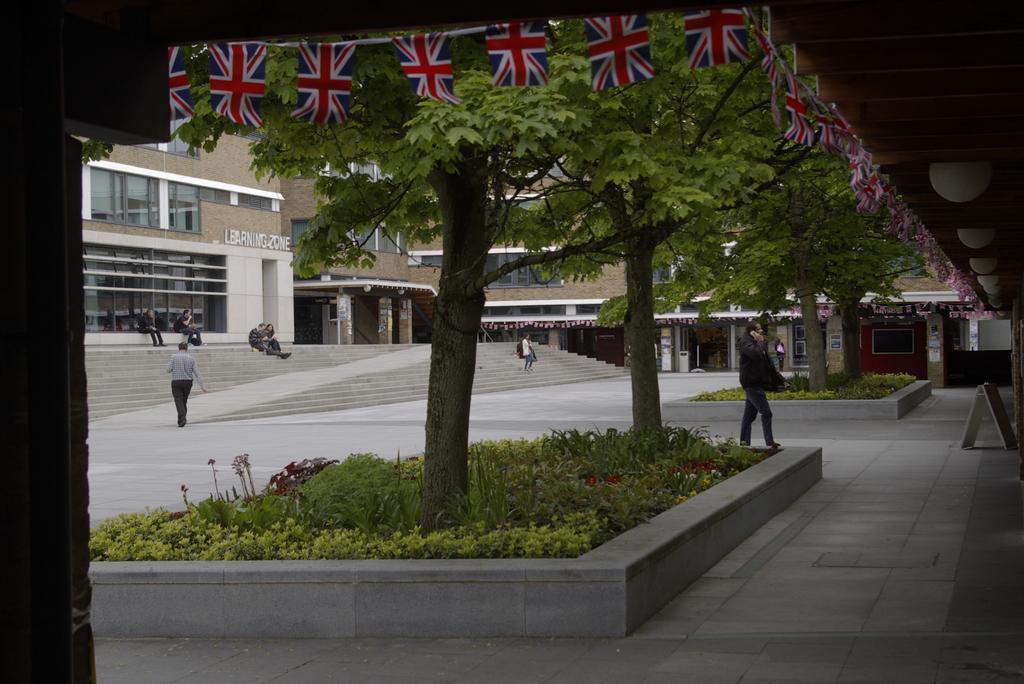In one or two sentences, can you explain what this image depicts? In this image, we can see buildings, trees, some people sitting on the stairs and some are walking and we can see some plants. At the bottom, there is floor. 